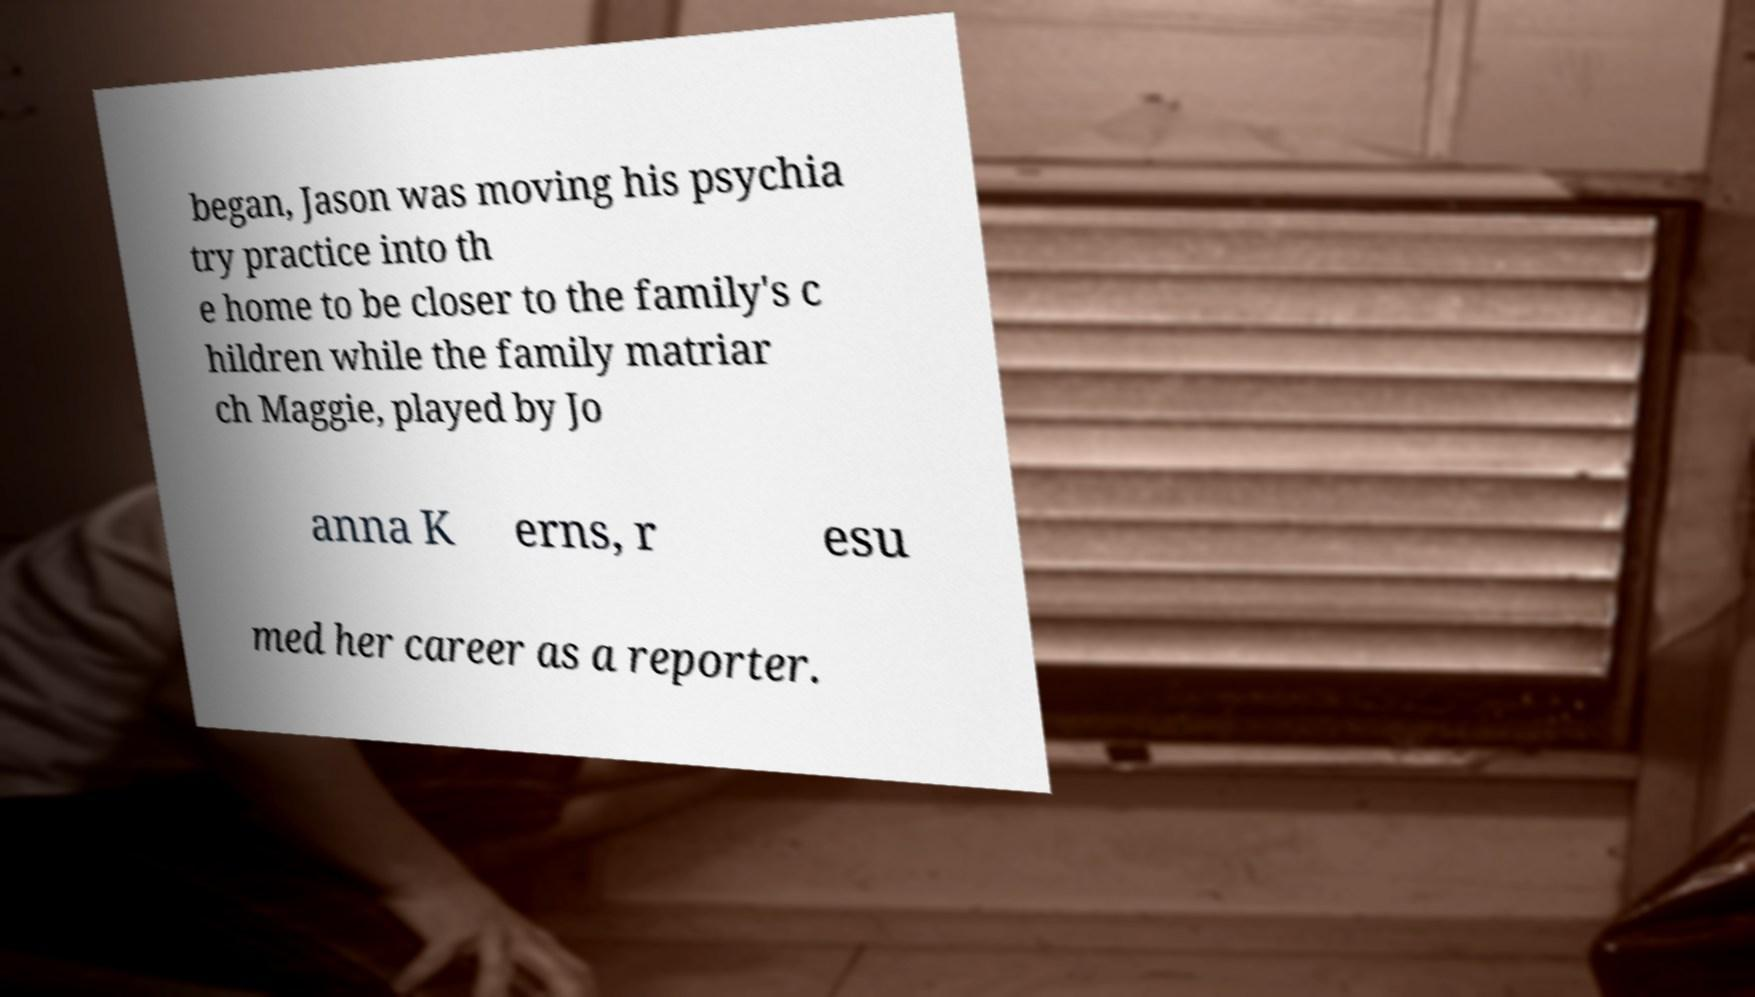Could you extract and type out the text from this image? began, Jason was moving his psychia try practice into th e home to be closer to the family's c hildren while the family matriar ch Maggie, played by Jo anna K erns, r esu med her career as a reporter. 